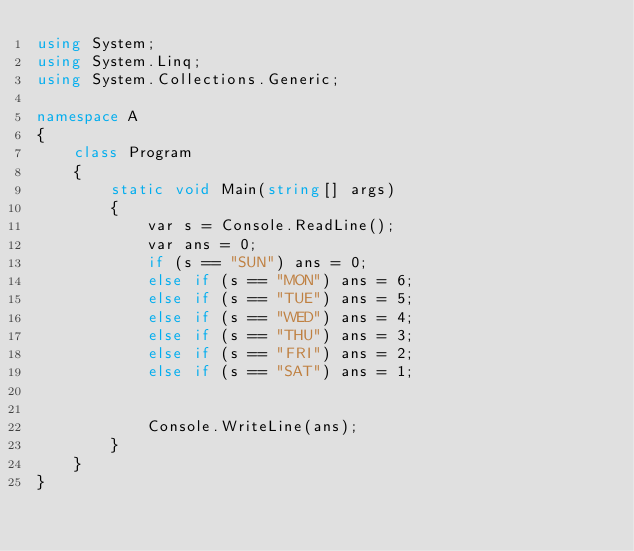Convert code to text. <code><loc_0><loc_0><loc_500><loc_500><_C#_>using System;
using System.Linq;
using System.Collections.Generic;

namespace A
{
    class Program
    {
        static void Main(string[] args)
        {
            var s = Console.ReadLine();
            var ans = 0;
            if (s == "SUN") ans = 0;
            else if (s == "MON") ans = 6;
            else if (s == "TUE") ans = 5;
            else if (s == "WED") ans = 4;
            else if (s == "THU") ans = 3;
            else if (s == "FRI") ans = 2;
            else if (s == "SAT") ans = 1;


            Console.WriteLine(ans);
        }
    }
}
</code> 